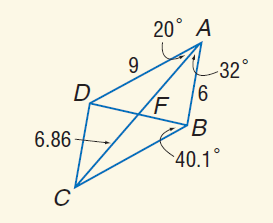Answer the mathemtical geometry problem and directly provide the correct option letter.
Question: Use parallelogram A B C D to find m \angle B C D.
Choices: A: 20 B: 32 C: 52 D: 128 C 